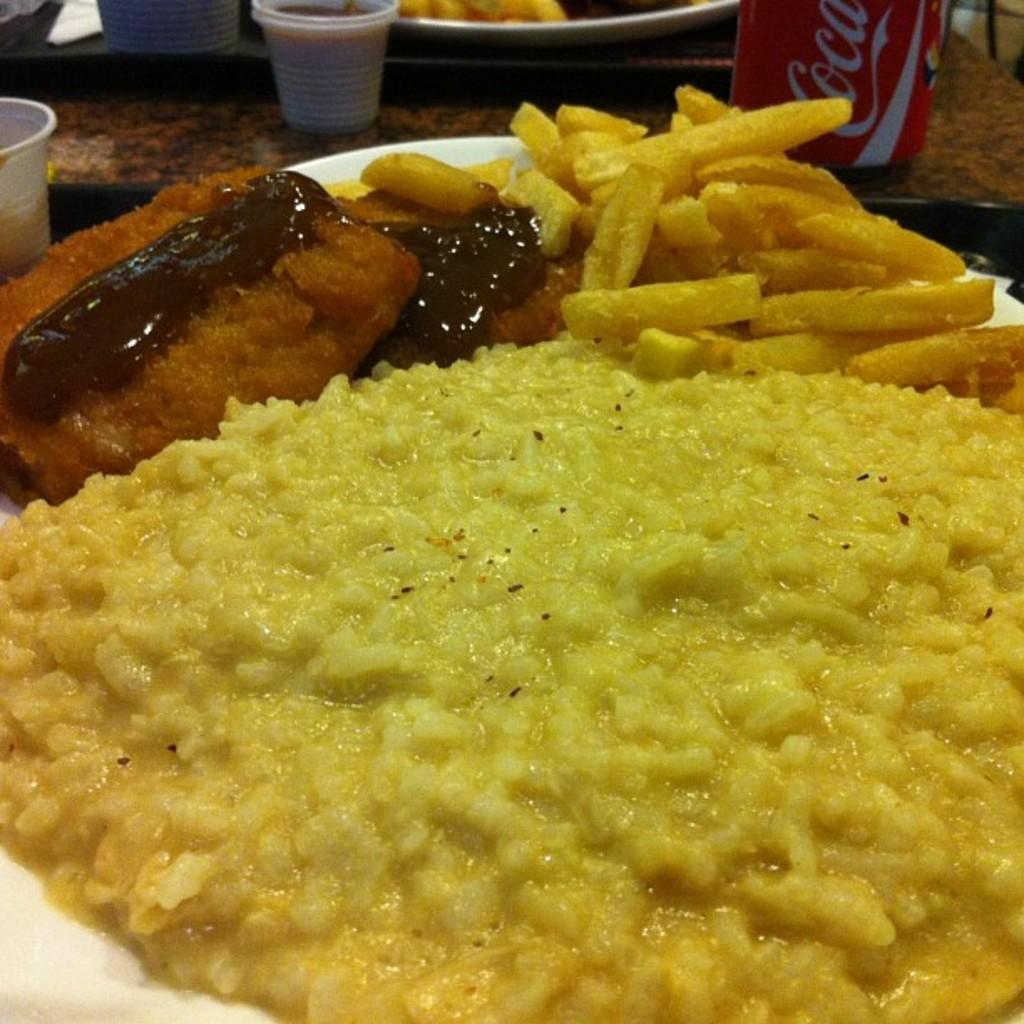What type of objects can be seen on tables in the image? There are plates, food, a tin, and cups on tables in the image. What might be used for serving or eating food in the image? The plates and cups can be used for serving or eating food in the image. What is the tin used for in the image? The purpose of the tin in the image is not specified, but it could be used for storing or serving food or other items. Is there a gun being used to cook the food in the image? No, there is no gun present in the image. The objects visible are plates, food, a tin, and cups, all of which are on tables. 